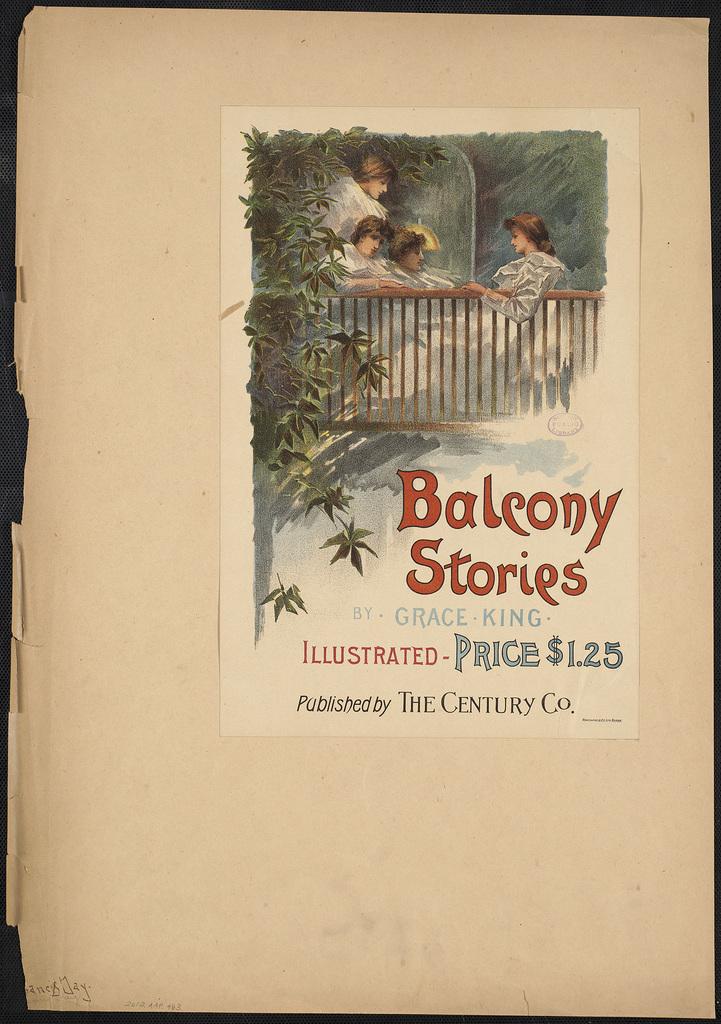How much did this book cost?
Your response must be concise. $1.25. 